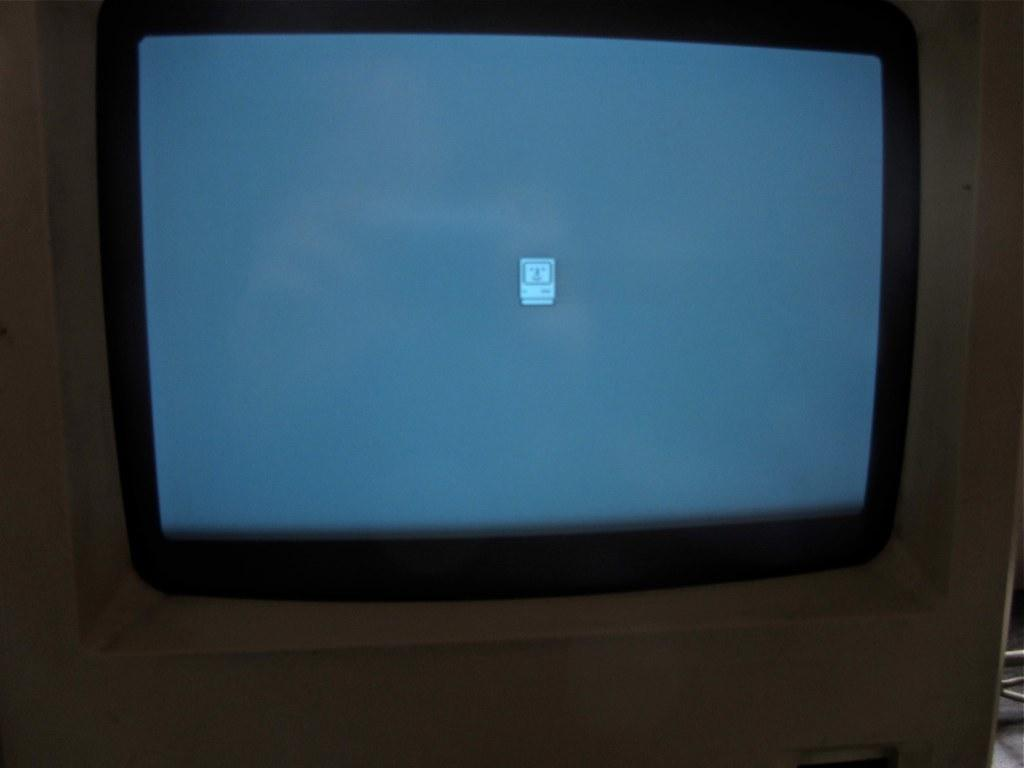What electronic device can be seen in the image? There is a TV in the image. How is the TV positioned in the room? The TV is mounted to the wall. What type of songs can be heard playing from the TV in the image? There is no indication of any songs playing in the image, as it only shows a TV mounted to the wall. 